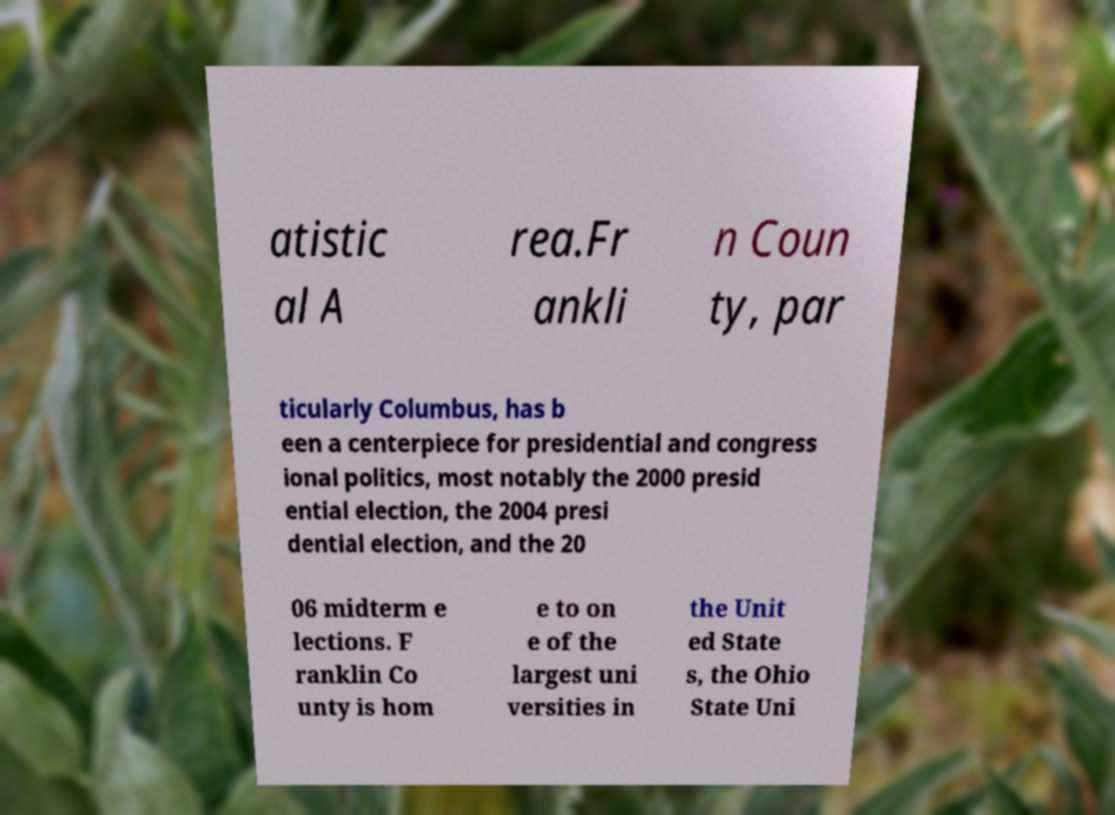Can you accurately transcribe the text from the provided image for me? atistic al A rea.Fr ankli n Coun ty, par ticularly Columbus, has b een a centerpiece for presidential and congress ional politics, most notably the 2000 presid ential election, the 2004 presi dential election, and the 20 06 midterm e lections. F ranklin Co unty is hom e to on e of the largest uni versities in the Unit ed State s, the Ohio State Uni 